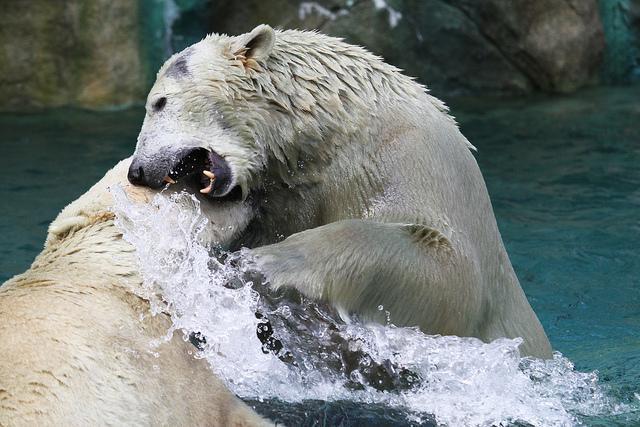How many bears are there?
Give a very brief answer. 2. 